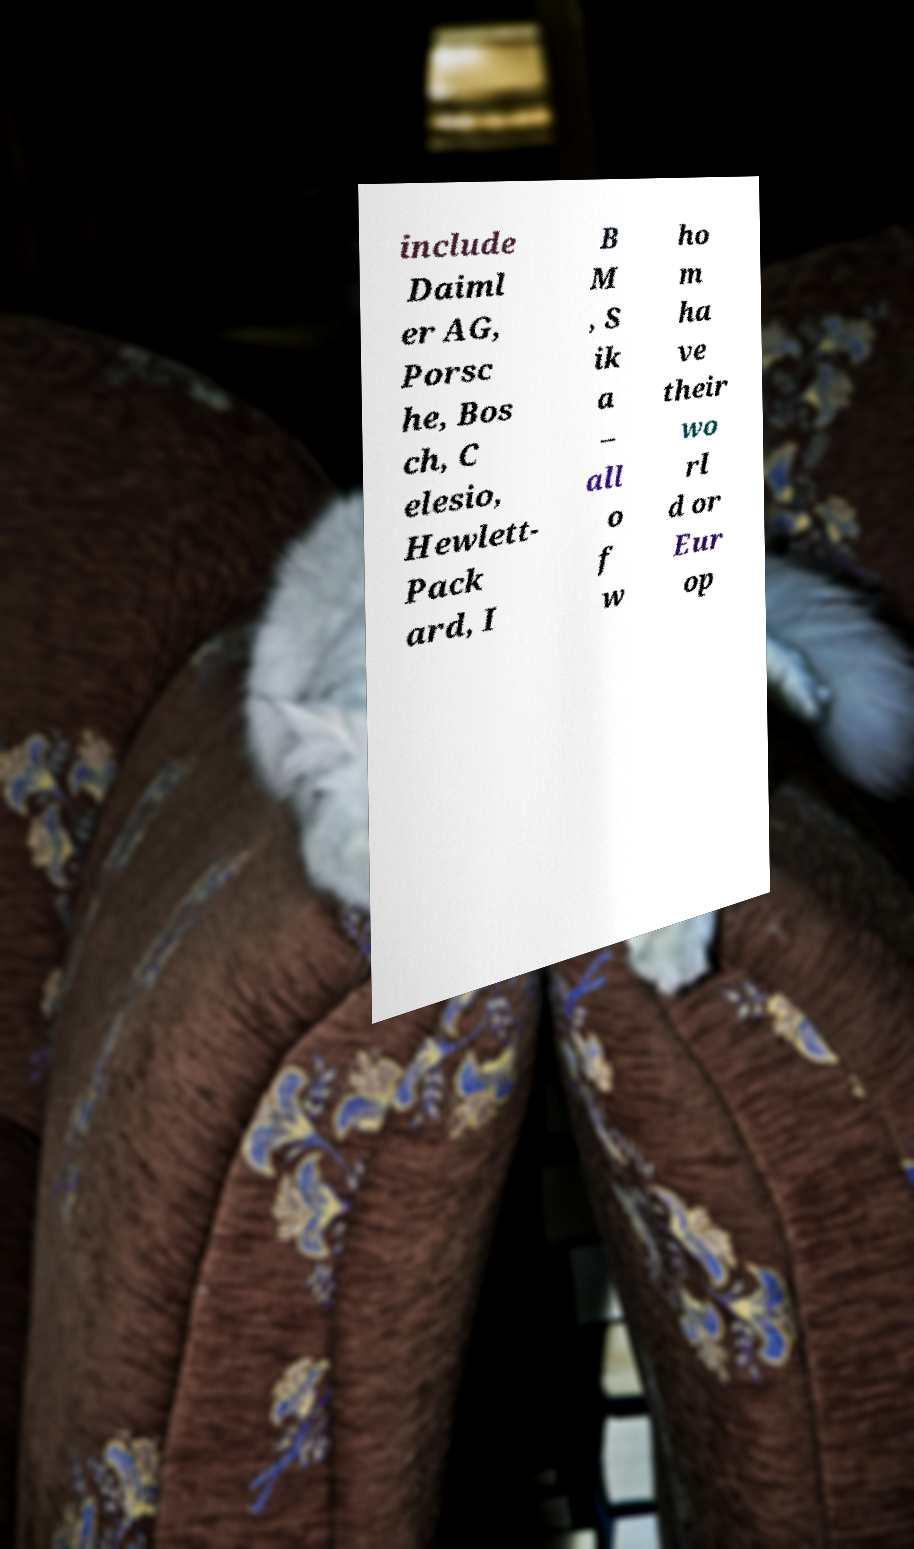Can you read and provide the text displayed in the image?This photo seems to have some interesting text. Can you extract and type it out for me? include Daiml er AG, Porsc he, Bos ch, C elesio, Hewlett- Pack ard, I B M , S ik a – all o f w ho m ha ve their wo rl d or Eur op 